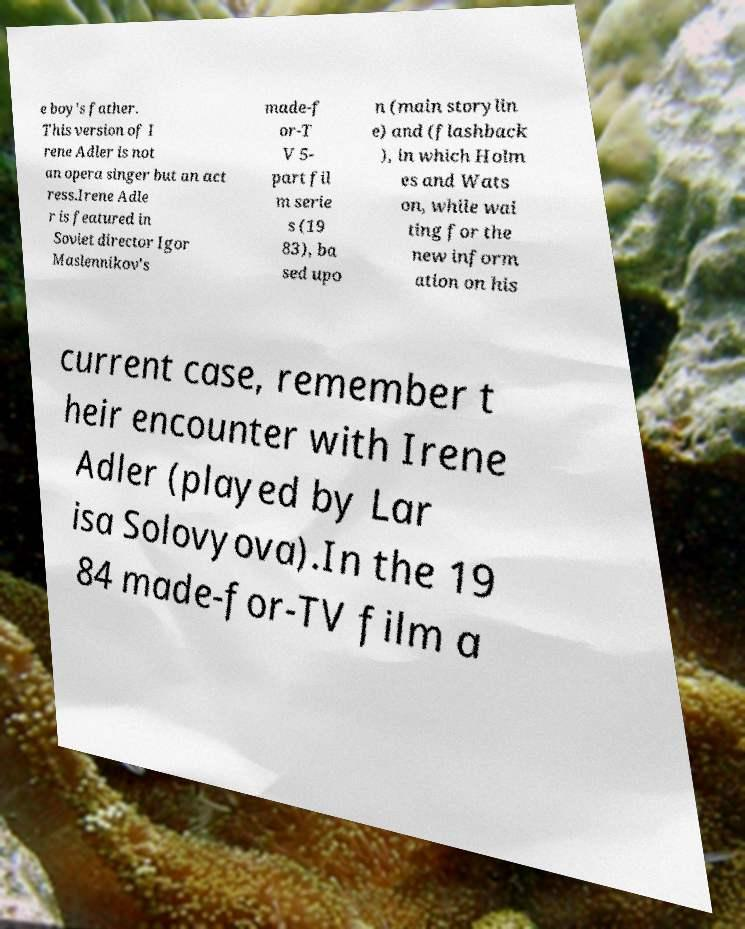There's text embedded in this image that I need extracted. Can you transcribe it verbatim? e boy's father. This version of I rene Adler is not an opera singer but an act ress.Irene Adle r is featured in Soviet director Igor Maslennikov's made-f or-T V 5- part fil m serie s (19 83), ba sed upo n (main storylin e) and (flashback ), in which Holm es and Wats on, while wai ting for the new inform ation on his current case, remember t heir encounter with Irene Adler (played by Lar isa Solovyova).In the 19 84 made-for-TV film a 